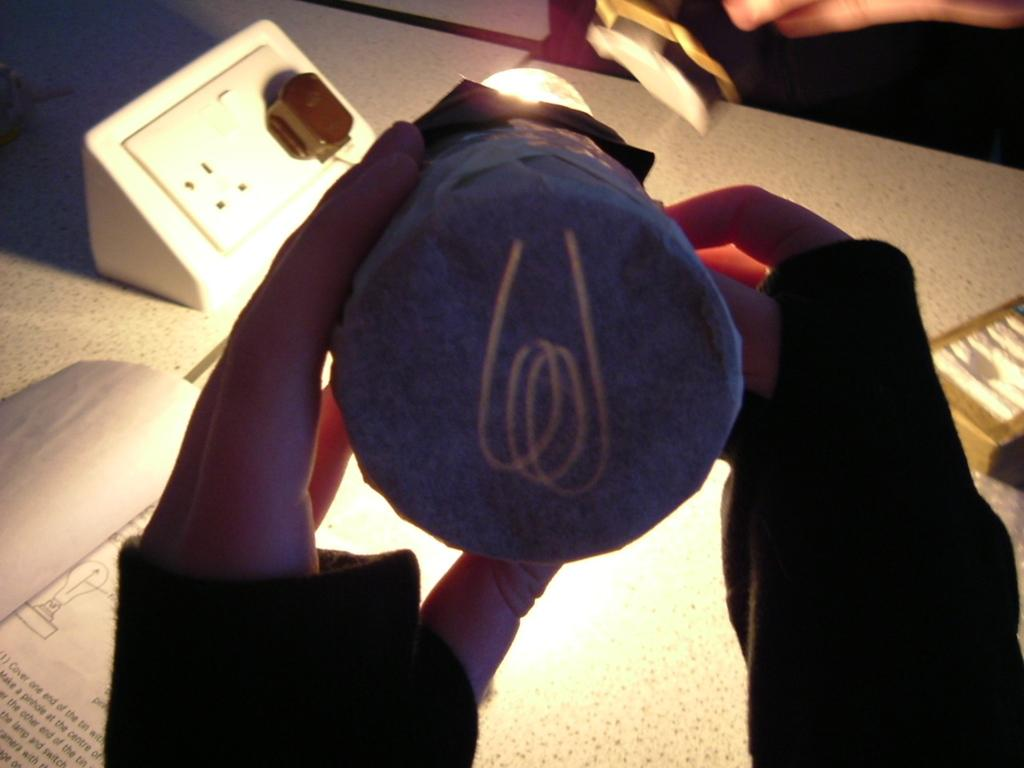What is the person holding in their hand in the image? There is an object held in a person's hand in the image. What can be seen on the table in the image? There are objects on a table in the image. What type of berry can be seen growing on the table in the image? There are no berries present in the image, and the objects on the table do not include any plants or fruits. 